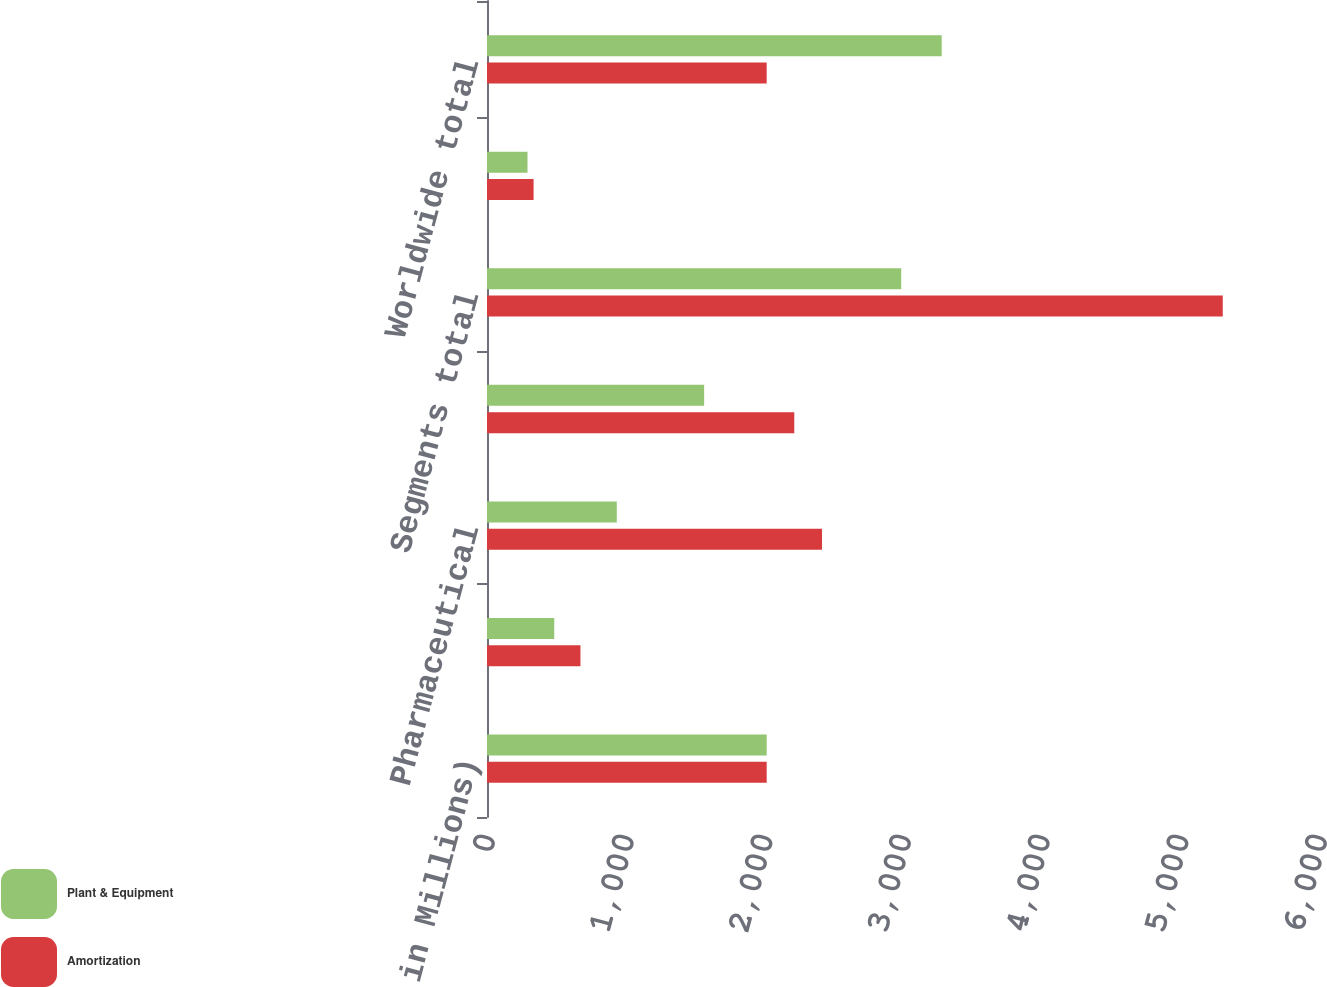Convert chart to OTSL. <chart><loc_0><loc_0><loc_500><loc_500><stacked_bar_chart><ecel><fcel>(Dollars in Millions)<fcel>Consumer<fcel>Pharmaceutical<fcel>Medical Devices<fcel>Segments total<fcel>General corporate<fcel>Worldwide total<nl><fcel>Plant & Equipment<fcel>2017<fcel>485<fcel>936<fcel>1566<fcel>2987<fcel>292<fcel>3279<nl><fcel>Amortization<fcel>2017<fcel>674<fcel>2416<fcel>2216<fcel>5306<fcel>336<fcel>2017<nl></chart> 